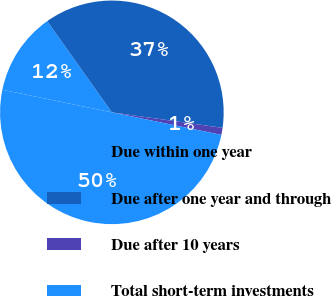<chart> <loc_0><loc_0><loc_500><loc_500><pie_chart><fcel>Due within one year<fcel>Due after one year and through<fcel>Due after 10 years<fcel>Total short-term investments<nl><fcel>11.95%<fcel>37.03%<fcel>1.02%<fcel>50.0%<nl></chart> 